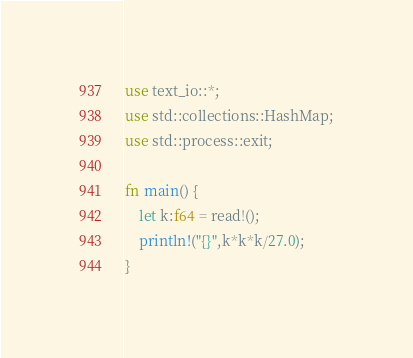Convert code to text. <code><loc_0><loc_0><loc_500><loc_500><_Rust_>use text_io::*;
use std::collections::HashMap;
use std::process::exit;

fn main() {
    let k:f64 = read!();
    println!("{}",k*k*k/27.0);
}</code> 